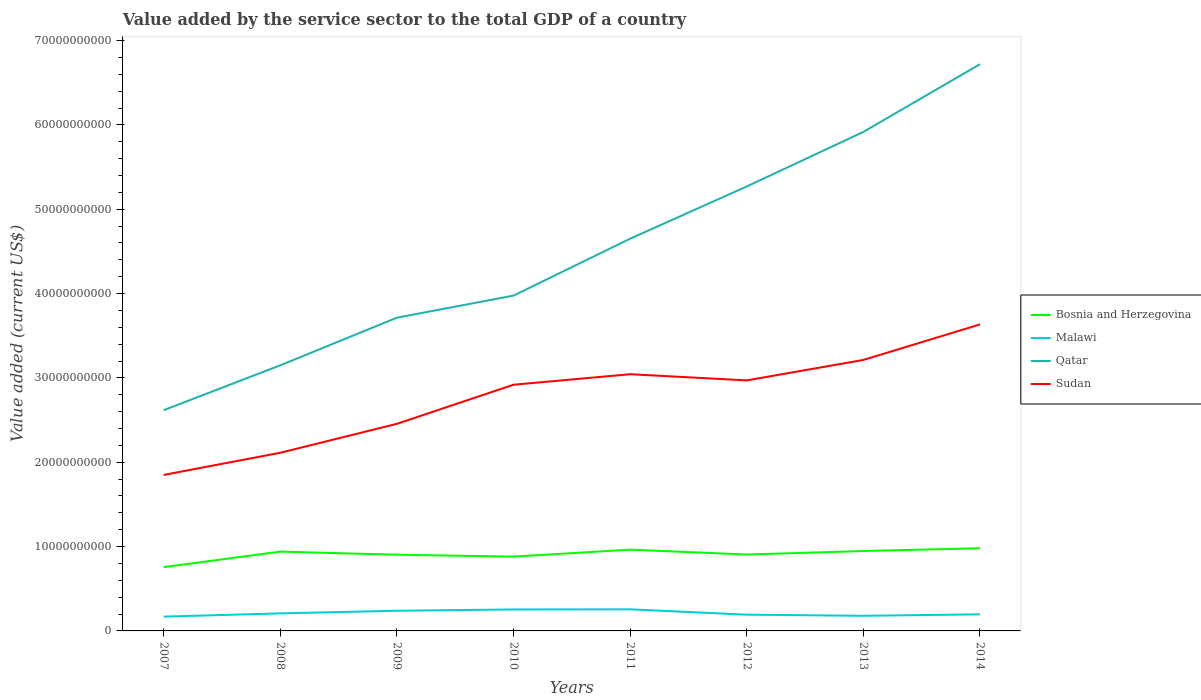Does the line corresponding to Malawi intersect with the line corresponding to Qatar?
Your response must be concise. No. Is the number of lines equal to the number of legend labels?
Offer a terse response. Yes. Across all years, what is the maximum value added by the service sector to the total GDP in Bosnia and Herzegovina?
Give a very brief answer. 7.56e+09. What is the total value added by the service sector to the total GDP in Sudan in the graph?
Offer a very short reply. -6.64e+09. What is the difference between the highest and the second highest value added by the service sector to the total GDP in Bosnia and Herzegovina?
Ensure brevity in your answer.  2.24e+09. What is the difference between the highest and the lowest value added by the service sector to the total GDP in Malawi?
Give a very brief answer. 3. How many lines are there?
Offer a terse response. 4. Are the values on the major ticks of Y-axis written in scientific E-notation?
Keep it short and to the point. No. Does the graph contain any zero values?
Your answer should be very brief. No. Does the graph contain grids?
Your answer should be very brief. No. Where does the legend appear in the graph?
Keep it short and to the point. Center right. How many legend labels are there?
Offer a terse response. 4. How are the legend labels stacked?
Provide a succinct answer. Vertical. What is the title of the graph?
Your answer should be very brief. Value added by the service sector to the total GDP of a country. Does "Djibouti" appear as one of the legend labels in the graph?
Provide a succinct answer. No. What is the label or title of the X-axis?
Keep it short and to the point. Years. What is the label or title of the Y-axis?
Offer a terse response. Value added (current US$). What is the Value added (current US$) of Bosnia and Herzegovina in 2007?
Ensure brevity in your answer.  7.56e+09. What is the Value added (current US$) in Malawi in 2007?
Your response must be concise. 1.69e+09. What is the Value added (current US$) in Qatar in 2007?
Your response must be concise. 2.62e+1. What is the Value added (current US$) in Sudan in 2007?
Give a very brief answer. 1.85e+1. What is the Value added (current US$) of Bosnia and Herzegovina in 2008?
Your response must be concise. 9.40e+09. What is the Value added (current US$) in Malawi in 2008?
Your answer should be compact. 2.08e+09. What is the Value added (current US$) of Qatar in 2008?
Keep it short and to the point. 3.15e+1. What is the Value added (current US$) in Sudan in 2008?
Make the answer very short. 2.11e+1. What is the Value added (current US$) in Bosnia and Herzegovina in 2009?
Keep it short and to the point. 9.04e+09. What is the Value added (current US$) in Malawi in 2009?
Keep it short and to the point. 2.39e+09. What is the Value added (current US$) in Qatar in 2009?
Keep it short and to the point. 3.71e+1. What is the Value added (current US$) of Sudan in 2009?
Provide a short and direct response. 2.46e+1. What is the Value added (current US$) in Bosnia and Herzegovina in 2010?
Your answer should be compact. 8.81e+09. What is the Value added (current US$) in Malawi in 2010?
Make the answer very short. 2.54e+09. What is the Value added (current US$) in Qatar in 2010?
Give a very brief answer. 3.98e+1. What is the Value added (current US$) in Sudan in 2010?
Make the answer very short. 2.92e+1. What is the Value added (current US$) of Bosnia and Herzegovina in 2011?
Ensure brevity in your answer.  9.64e+09. What is the Value added (current US$) in Malawi in 2011?
Give a very brief answer. 2.56e+09. What is the Value added (current US$) of Qatar in 2011?
Ensure brevity in your answer.  4.65e+1. What is the Value added (current US$) of Sudan in 2011?
Your answer should be very brief. 3.04e+1. What is the Value added (current US$) of Bosnia and Herzegovina in 2012?
Ensure brevity in your answer.  9.06e+09. What is the Value added (current US$) of Malawi in 2012?
Your answer should be compact. 1.93e+09. What is the Value added (current US$) of Qatar in 2012?
Your answer should be very brief. 5.27e+1. What is the Value added (current US$) in Sudan in 2012?
Give a very brief answer. 2.97e+1. What is the Value added (current US$) in Bosnia and Herzegovina in 2013?
Give a very brief answer. 9.47e+09. What is the Value added (current US$) of Malawi in 2013?
Your answer should be compact. 1.79e+09. What is the Value added (current US$) of Qatar in 2013?
Offer a terse response. 5.92e+1. What is the Value added (current US$) of Sudan in 2013?
Provide a succinct answer. 3.21e+1. What is the Value added (current US$) in Bosnia and Herzegovina in 2014?
Your answer should be very brief. 9.80e+09. What is the Value added (current US$) in Malawi in 2014?
Your answer should be compact. 1.97e+09. What is the Value added (current US$) in Qatar in 2014?
Keep it short and to the point. 6.72e+1. What is the Value added (current US$) of Sudan in 2014?
Offer a very short reply. 3.63e+1. Across all years, what is the maximum Value added (current US$) in Bosnia and Herzegovina?
Offer a very short reply. 9.80e+09. Across all years, what is the maximum Value added (current US$) of Malawi?
Keep it short and to the point. 2.56e+09. Across all years, what is the maximum Value added (current US$) of Qatar?
Your response must be concise. 6.72e+1. Across all years, what is the maximum Value added (current US$) of Sudan?
Keep it short and to the point. 3.63e+1. Across all years, what is the minimum Value added (current US$) in Bosnia and Herzegovina?
Provide a succinct answer. 7.56e+09. Across all years, what is the minimum Value added (current US$) in Malawi?
Your answer should be very brief. 1.69e+09. Across all years, what is the minimum Value added (current US$) in Qatar?
Your answer should be compact. 2.62e+1. Across all years, what is the minimum Value added (current US$) of Sudan?
Ensure brevity in your answer.  1.85e+1. What is the total Value added (current US$) of Bosnia and Herzegovina in the graph?
Provide a succinct answer. 7.28e+1. What is the total Value added (current US$) of Malawi in the graph?
Offer a terse response. 1.70e+1. What is the total Value added (current US$) of Qatar in the graph?
Ensure brevity in your answer.  3.60e+11. What is the total Value added (current US$) of Sudan in the graph?
Your answer should be very brief. 2.22e+11. What is the difference between the Value added (current US$) of Bosnia and Herzegovina in 2007 and that in 2008?
Keep it short and to the point. -1.84e+09. What is the difference between the Value added (current US$) of Malawi in 2007 and that in 2008?
Offer a terse response. -3.86e+08. What is the difference between the Value added (current US$) in Qatar in 2007 and that in 2008?
Give a very brief answer. -5.32e+09. What is the difference between the Value added (current US$) in Sudan in 2007 and that in 2008?
Keep it short and to the point. -2.63e+09. What is the difference between the Value added (current US$) of Bosnia and Herzegovina in 2007 and that in 2009?
Offer a terse response. -1.47e+09. What is the difference between the Value added (current US$) of Malawi in 2007 and that in 2009?
Keep it short and to the point. -6.97e+08. What is the difference between the Value added (current US$) in Qatar in 2007 and that in 2009?
Give a very brief answer. -1.10e+1. What is the difference between the Value added (current US$) of Sudan in 2007 and that in 2009?
Your answer should be compact. -6.06e+09. What is the difference between the Value added (current US$) in Bosnia and Herzegovina in 2007 and that in 2010?
Provide a short and direct response. -1.25e+09. What is the difference between the Value added (current US$) of Malawi in 2007 and that in 2010?
Give a very brief answer. -8.50e+08. What is the difference between the Value added (current US$) of Qatar in 2007 and that in 2010?
Offer a terse response. -1.36e+1. What is the difference between the Value added (current US$) in Sudan in 2007 and that in 2010?
Keep it short and to the point. -1.07e+1. What is the difference between the Value added (current US$) of Bosnia and Herzegovina in 2007 and that in 2011?
Your answer should be very brief. -2.07e+09. What is the difference between the Value added (current US$) of Malawi in 2007 and that in 2011?
Ensure brevity in your answer.  -8.66e+08. What is the difference between the Value added (current US$) in Qatar in 2007 and that in 2011?
Your answer should be very brief. -2.03e+1. What is the difference between the Value added (current US$) in Sudan in 2007 and that in 2011?
Ensure brevity in your answer.  -1.19e+1. What is the difference between the Value added (current US$) in Bosnia and Herzegovina in 2007 and that in 2012?
Your answer should be very brief. -1.49e+09. What is the difference between the Value added (current US$) of Malawi in 2007 and that in 2012?
Give a very brief answer. -2.32e+08. What is the difference between the Value added (current US$) of Qatar in 2007 and that in 2012?
Keep it short and to the point. -2.65e+1. What is the difference between the Value added (current US$) in Sudan in 2007 and that in 2012?
Give a very brief answer. -1.12e+1. What is the difference between the Value added (current US$) of Bosnia and Herzegovina in 2007 and that in 2013?
Make the answer very short. -1.91e+09. What is the difference between the Value added (current US$) in Malawi in 2007 and that in 2013?
Provide a succinct answer. -9.82e+07. What is the difference between the Value added (current US$) of Qatar in 2007 and that in 2013?
Offer a terse response. -3.30e+1. What is the difference between the Value added (current US$) of Sudan in 2007 and that in 2013?
Make the answer very short. -1.36e+1. What is the difference between the Value added (current US$) in Bosnia and Herzegovina in 2007 and that in 2014?
Your answer should be compact. -2.24e+09. What is the difference between the Value added (current US$) of Malawi in 2007 and that in 2014?
Offer a terse response. -2.74e+08. What is the difference between the Value added (current US$) of Qatar in 2007 and that in 2014?
Make the answer very short. -4.10e+1. What is the difference between the Value added (current US$) in Sudan in 2007 and that in 2014?
Offer a very short reply. -1.78e+1. What is the difference between the Value added (current US$) of Bosnia and Herzegovina in 2008 and that in 2009?
Ensure brevity in your answer.  3.69e+08. What is the difference between the Value added (current US$) in Malawi in 2008 and that in 2009?
Make the answer very short. -3.12e+08. What is the difference between the Value added (current US$) of Qatar in 2008 and that in 2009?
Your answer should be very brief. -5.65e+09. What is the difference between the Value added (current US$) of Sudan in 2008 and that in 2009?
Ensure brevity in your answer.  -3.43e+09. What is the difference between the Value added (current US$) in Bosnia and Herzegovina in 2008 and that in 2010?
Give a very brief answer. 5.95e+08. What is the difference between the Value added (current US$) of Malawi in 2008 and that in 2010?
Keep it short and to the point. -4.65e+08. What is the difference between the Value added (current US$) in Qatar in 2008 and that in 2010?
Offer a terse response. -8.27e+09. What is the difference between the Value added (current US$) of Sudan in 2008 and that in 2010?
Offer a terse response. -8.07e+09. What is the difference between the Value added (current US$) in Bosnia and Herzegovina in 2008 and that in 2011?
Your answer should be compact. -2.33e+08. What is the difference between the Value added (current US$) of Malawi in 2008 and that in 2011?
Provide a short and direct response. -4.81e+08. What is the difference between the Value added (current US$) in Qatar in 2008 and that in 2011?
Your answer should be compact. -1.50e+1. What is the difference between the Value added (current US$) of Sudan in 2008 and that in 2011?
Make the answer very short. -9.31e+09. What is the difference between the Value added (current US$) in Bosnia and Herzegovina in 2008 and that in 2012?
Keep it short and to the point. 3.47e+08. What is the difference between the Value added (current US$) of Malawi in 2008 and that in 2012?
Provide a short and direct response. 1.53e+08. What is the difference between the Value added (current US$) of Qatar in 2008 and that in 2012?
Offer a terse response. -2.12e+1. What is the difference between the Value added (current US$) in Sudan in 2008 and that in 2012?
Your response must be concise. -8.58e+09. What is the difference between the Value added (current US$) in Bosnia and Herzegovina in 2008 and that in 2013?
Give a very brief answer. -6.98e+07. What is the difference between the Value added (current US$) of Malawi in 2008 and that in 2013?
Keep it short and to the point. 2.87e+08. What is the difference between the Value added (current US$) in Qatar in 2008 and that in 2013?
Provide a short and direct response. -2.77e+1. What is the difference between the Value added (current US$) of Sudan in 2008 and that in 2013?
Your answer should be very brief. -1.10e+1. What is the difference between the Value added (current US$) of Bosnia and Herzegovina in 2008 and that in 2014?
Ensure brevity in your answer.  -4.00e+08. What is the difference between the Value added (current US$) in Malawi in 2008 and that in 2014?
Provide a succinct answer. 1.12e+08. What is the difference between the Value added (current US$) in Qatar in 2008 and that in 2014?
Offer a terse response. -3.57e+1. What is the difference between the Value added (current US$) in Sudan in 2008 and that in 2014?
Offer a terse response. -1.52e+1. What is the difference between the Value added (current US$) in Bosnia and Herzegovina in 2009 and that in 2010?
Offer a very short reply. 2.26e+08. What is the difference between the Value added (current US$) of Malawi in 2009 and that in 2010?
Your response must be concise. -1.53e+08. What is the difference between the Value added (current US$) of Qatar in 2009 and that in 2010?
Your answer should be compact. -2.62e+09. What is the difference between the Value added (current US$) of Sudan in 2009 and that in 2010?
Keep it short and to the point. -4.64e+09. What is the difference between the Value added (current US$) of Bosnia and Herzegovina in 2009 and that in 2011?
Offer a terse response. -6.02e+08. What is the difference between the Value added (current US$) in Malawi in 2009 and that in 2011?
Ensure brevity in your answer.  -1.69e+08. What is the difference between the Value added (current US$) of Qatar in 2009 and that in 2011?
Your response must be concise. -9.36e+09. What is the difference between the Value added (current US$) in Sudan in 2009 and that in 2011?
Give a very brief answer. -5.88e+09. What is the difference between the Value added (current US$) of Bosnia and Herzegovina in 2009 and that in 2012?
Ensure brevity in your answer.  -2.16e+07. What is the difference between the Value added (current US$) of Malawi in 2009 and that in 2012?
Provide a short and direct response. 4.65e+08. What is the difference between the Value added (current US$) in Qatar in 2009 and that in 2012?
Ensure brevity in your answer.  -1.56e+1. What is the difference between the Value added (current US$) of Sudan in 2009 and that in 2012?
Make the answer very short. -5.15e+09. What is the difference between the Value added (current US$) of Bosnia and Herzegovina in 2009 and that in 2013?
Offer a terse response. -4.38e+08. What is the difference between the Value added (current US$) of Malawi in 2009 and that in 2013?
Your response must be concise. 5.99e+08. What is the difference between the Value added (current US$) in Qatar in 2009 and that in 2013?
Provide a succinct answer. -2.20e+1. What is the difference between the Value added (current US$) of Sudan in 2009 and that in 2013?
Provide a succinct answer. -7.57e+09. What is the difference between the Value added (current US$) in Bosnia and Herzegovina in 2009 and that in 2014?
Provide a short and direct response. -7.69e+08. What is the difference between the Value added (current US$) in Malawi in 2009 and that in 2014?
Offer a terse response. 4.23e+08. What is the difference between the Value added (current US$) of Qatar in 2009 and that in 2014?
Your answer should be very brief. -3.01e+1. What is the difference between the Value added (current US$) of Sudan in 2009 and that in 2014?
Make the answer very short. -1.18e+1. What is the difference between the Value added (current US$) in Bosnia and Herzegovina in 2010 and that in 2011?
Your answer should be compact. -8.27e+08. What is the difference between the Value added (current US$) in Malawi in 2010 and that in 2011?
Provide a short and direct response. -1.59e+07. What is the difference between the Value added (current US$) in Qatar in 2010 and that in 2011?
Keep it short and to the point. -6.75e+09. What is the difference between the Value added (current US$) of Sudan in 2010 and that in 2011?
Provide a short and direct response. -1.25e+09. What is the difference between the Value added (current US$) of Bosnia and Herzegovina in 2010 and that in 2012?
Your response must be concise. -2.48e+08. What is the difference between the Value added (current US$) of Malawi in 2010 and that in 2012?
Your answer should be very brief. 6.18e+08. What is the difference between the Value added (current US$) in Qatar in 2010 and that in 2012?
Keep it short and to the point. -1.29e+1. What is the difference between the Value added (current US$) in Sudan in 2010 and that in 2012?
Offer a very short reply. -5.12e+08. What is the difference between the Value added (current US$) in Bosnia and Herzegovina in 2010 and that in 2013?
Provide a short and direct response. -6.64e+08. What is the difference between the Value added (current US$) in Malawi in 2010 and that in 2013?
Provide a short and direct response. 7.52e+08. What is the difference between the Value added (current US$) in Qatar in 2010 and that in 2013?
Ensure brevity in your answer.  -1.94e+1. What is the difference between the Value added (current US$) in Sudan in 2010 and that in 2013?
Keep it short and to the point. -2.94e+09. What is the difference between the Value added (current US$) of Bosnia and Herzegovina in 2010 and that in 2014?
Make the answer very short. -9.95e+08. What is the difference between the Value added (current US$) of Malawi in 2010 and that in 2014?
Give a very brief answer. 5.76e+08. What is the difference between the Value added (current US$) in Qatar in 2010 and that in 2014?
Give a very brief answer. -2.74e+1. What is the difference between the Value added (current US$) of Sudan in 2010 and that in 2014?
Keep it short and to the point. -7.15e+09. What is the difference between the Value added (current US$) of Bosnia and Herzegovina in 2011 and that in 2012?
Provide a succinct answer. 5.80e+08. What is the difference between the Value added (current US$) of Malawi in 2011 and that in 2012?
Your answer should be very brief. 6.34e+08. What is the difference between the Value added (current US$) in Qatar in 2011 and that in 2012?
Your answer should be compact. -6.19e+09. What is the difference between the Value added (current US$) of Sudan in 2011 and that in 2012?
Provide a short and direct response. 7.33e+08. What is the difference between the Value added (current US$) of Bosnia and Herzegovina in 2011 and that in 2013?
Provide a succinct answer. 1.63e+08. What is the difference between the Value added (current US$) in Malawi in 2011 and that in 2013?
Keep it short and to the point. 7.68e+08. What is the difference between the Value added (current US$) of Qatar in 2011 and that in 2013?
Your answer should be compact. -1.27e+1. What is the difference between the Value added (current US$) in Sudan in 2011 and that in 2013?
Your answer should be very brief. -1.69e+09. What is the difference between the Value added (current US$) in Bosnia and Herzegovina in 2011 and that in 2014?
Your answer should be compact. -1.67e+08. What is the difference between the Value added (current US$) of Malawi in 2011 and that in 2014?
Offer a very short reply. 5.92e+08. What is the difference between the Value added (current US$) of Qatar in 2011 and that in 2014?
Keep it short and to the point. -2.07e+1. What is the difference between the Value added (current US$) of Sudan in 2011 and that in 2014?
Give a very brief answer. -5.91e+09. What is the difference between the Value added (current US$) of Bosnia and Herzegovina in 2012 and that in 2013?
Ensure brevity in your answer.  -4.17e+08. What is the difference between the Value added (current US$) of Malawi in 2012 and that in 2013?
Give a very brief answer. 1.34e+08. What is the difference between the Value added (current US$) in Qatar in 2012 and that in 2013?
Ensure brevity in your answer.  -6.47e+09. What is the difference between the Value added (current US$) of Sudan in 2012 and that in 2013?
Provide a succinct answer. -2.43e+09. What is the difference between the Value added (current US$) in Bosnia and Herzegovina in 2012 and that in 2014?
Your response must be concise. -7.47e+08. What is the difference between the Value added (current US$) of Malawi in 2012 and that in 2014?
Your answer should be compact. -4.18e+07. What is the difference between the Value added (current US$) of Qatar in 2012 and that in 2014?
Your answer should be very brief. -1.45e+1. What is the difference between the Value added (current US$) of Sudan in 2012 and that in 2014?
Keep it short and to the point. -6.64e+09. What is the difference between the Value added (current US$) in Bosnia and Herzegovina in 2013 and that in 2014?
Offer a very short reply. -3.30e+08. What is the difference between the Value added (current US$) in Malawi in 2013 and that in 2014?
Your response must be concise. -1.76e+08. What is the difference between the Value added (current US$) in Qatar in 2013 and that in 2014?
Provide a short and direct response. -8.03e+09. What is the difference between the Value added (current US$) of Sudan in 2013 and that in 2014?
Keep it short and to the point. -4.22e+09. What is the difference between the Value added (current US$) in Bosnia and Herzegovina in 2007 and the Value added (current US$) in Malawi in 2008?
Give a very brief answer. 5.48e+09. What is the difference between the Value added (current US$) in Bosnia and Herzegovina in 2007 and the Value added (current US$) in Qatar in 2008?
Keep it short and to the point. -2.39e+1. What is the difference between the Value added (current US$) in Bosnia and Herzegovina in 2007 and the Value added (current US$) in Sudan in 2008?
Provide a short and direct response. -1.36e+1. What is the difference between the Value added (current US$) in Malawi in 2007 and the Value added (current US$) in Qatar in 2008?
Give a very brief answer. -2.98e+1. What is the difference between the Value added (current US$) in Malawi in 2007 and the Value added (current US$) in Sudan in 2008?
Keep it short and to the point. -1.94e+1. What is the difference between the Value added (current US$) of Qatar in 2007 and the Value added (current US$) of Sudan in 2008?
Offer a very short reply. 5.05e+09. What is the difference between the Value added (current US$) in Bosnia and Herzegovina in 2007 and the Value added (current US$) in Malawi in 2009?
Ensure brevity in your answer.  5.17e+09. What is the difference between the Value added (current US$) in Bosnia and Herzegovina in 2007 and the Value added (current US$) in Qatar in 2009?
Your answer should be very brief. -2.96e+1. What is the difference between the Value added (current US$) of Bosnia and Herzegovina in 2007 and the Value added (current US$) of Sudan in 2009?
Offer a terse response. -1.70e+1. What is the difference between the Value added (current US$) of Malawi in 2007 and the Value added (current US$) of Qatar in 2009?
Offer a terse response. -3.54e+1. What is the difference between the Value added (current US$) of Malawi in 2007 and the Value added (current US$) of Sudan in 2009?
Your answer should be compact. -2.29e+1. What is the difference between the Value added (current US$) in Qatar in 2007 and the Value added (current US$) in Sudan in 2009?
Offer a terse response. 1.62e+09. What is the difference between the Value added (current US$) of Bosnia and Herzegovina in 2007 and the Value added (current US$) of Malawi in 2010?
Provide a short and direct response. 5.02e+09. What is the difference between the Value added (current US$) in Bosnia and Herzegovina in 2007 and the Value added (current US$) in Qatar in 2010?
Offer a terse response. -3.22e+1. What is the difference between the Value added (current US$) in Bosnia and Herzegovina in 2007 and the Value added (current US$) in Sudan in 2010?
Your answer should be very brief. -2.16e+1. What is the difference between the Value added (current US$) of Malawi in 2007 and the Value added (current US$) of Qatar in 2010?
Keep it short and to the point. -3.81e+1. What is the difference between the Value added (current US$) of Malawi in 2007 and the Value added (current US$) of Sudan in 2010?
Provide a succinct answer. -2.75e+1. What is the difference between the Value added (current US$) of Qatar in 2007 and the Value added (current US$) of Sudan in 2010?
Ensure brevity in your answer.  -3.02e+09. What is the difference between the Value added (current US$) in Bosnia and Herzegovina in 2007 and the Value added (current US$) in Malawi in 2011?
Your answer should be very brief. 5.00e+09. What is the difference between the Value added (current US$) in Bosnia and Herzegovina in 2007 and the Value added (current US$) in Qatar in 2011?
Your response must be concise. -3.89e+1. What is the difference between the Value added (current US$) of Bosnia and Herzegovina in 2007 and the Value added (current US$) of Sudan in 2011?
Keep it short and to the point. -2.29e+1. What is the difference between the Value added (current US$) of Malawi in 2007 and the Value added (current US$) of Qatar in 2011?
Your answer should be compact. -4.48e+1. What is the difference between the Value added (current US$) in Malawi in 2007 and the Value added (current US$) in Sudan in 2011?
Provide a short and direct response. -2.87e+1. What is the difference between the Value added (current US$) of Qatar in 2007 and the Value added (current US$) of Sudan in 2011?
Ensure brevity in your answer.  -4.26e+09. What is the difference between the Value added (current US$) in Bosnia and Herzegovina in 2007 and the Value added (current US$) in Malawi in 2012?
Keep it short and to the point. 5.64e+09. What is the difference between the Value added (current US$) of Bosnia and Herzegovina in 2007 and the Value added (current US$) of Qatar in 2012?
Keep it short and to the point. -4.51e+1. What is the difference between the Value added (current US$) of Bosnia and Herzegovina in 2007 and the Value added (current US$) of Sudan in 2012?
Offer a terse response. -2.21e+1. What is the difference between the Value added (current US$) in Malawi in 2007 and the Value added (current US$) in Qatar in 2012?
Make the answer very short. -5.10e+1. What is the difference between the Value added (current US$) of Malawi in 2007 and the Value added (current US$) of Sudan in 2012?
Keep it short and to the point. -2.80e+1. What is the difference between the Value added (current US$) of Qatar in 2007 and the Value added (current US$) of Sudan in 2012?
Ensure brevity in your answer.  -3.53e+09. What is the difference between the Value added (current US$) of Bosnia and Herzegovina in 2007 and the Value added (current US$) of Malawi in 2013?
Keep it short and to the point. 5.77e+09. What is the difference between the Value added (current US$) in Bosnia and Herzegovina in 2007 and the Value added (current US$) in Qatar in 2013?
Give a very brief answer. -5.16e+1. What is the difference between the Value added (current US$) in Bosnia and Herzegovina in 2007 and the Value added (current US$) in Sudan in 2013?
Keep it short and to the point. -2.46e+1. What is the difference between the Value added (current US$) of Malawi in 2007 and the Value added (current US$) of Qatar in 2013?
Make the answer very short. -5.75e+1. What is the difference between the Value added (current US$) in Malawi in 2007 and the Value added (current US$) in Sudan in 2013?
Ensure brevity in your answer.  -3.04e+1. What is the difference between the Value added (current US$) of Qatar in 2007 and the Value added (current US$) of Sudan in 2013?
Make the answer very short. -5.96e+09. What is the difference between the Value added (current US$) in Bosnia and Herzegovina in 2007 and the Value added (current US$) in Malawi in 2014?
Give a very brief answer. 5.59e+09. What is the difference between the Value added (current US$) of Bosnia and Herzegovina in 2007 and the Value added (current US$) of Qatar in 2014?
Your response must be concise. -5.96e+1. What is the difference between the Value added (current US$) in Bosnia and Herzegovina in 2007 and the Value added (current US$) in Sudan in 2014?
Provide a succinct answer. -2.88e+1. What is the difference between the Value added (current US$) of Malawi in 2007 and the Value added (current US$) of Qatar in 2014?
Offer a terse response. -6.55e+1. What is the difference between the Value added (current US$) of Malawi in 2007 and the Value added (current US$) of Sudan in 2014?
Your response must be concise. -3.47e+1. What is the difference between the Value added (current US$) in Qatar in 2007 and the Value added (current US$) in Sudan in 2014?
Offer a very short reply. -1.02e+1. What is the difference between the Value added (current US$) of Bosnia and Herzegovina in 2008 and the Value added (current US$) of Malawi in 2009?
Give a very brief answer. 7.01e+09. What is the difference between the Value added (current US$) in Bosnia and Herzegovina in 2008 and the Value added (current US$) in Qatar in 2009?
Your answer should be very brief. -2.77e+1. What is the difference between the Value added (current US$) of Bosnia and Herzegovina in 2008 and the Value added (current US$) of Sudan in 2009?
Give a very brief answer. -1.52e+1. What is the difference between the Value added (current US$) of Malawi in 2008 and the Value added (current US$) of Qatar in 2009?
Provide a succinct answer. -3.51e+1. What is the difference between the Value added (current US$) of Malawi in 2008 and the Value added (current US$) of Sudan in 2009?
Offer a very short reply. -2.25e+1. What is the difference between the Value added (current US$) of Qatar in 2008 and the Value added (current US$) of Sudan in 2009?
Offer a very short reply. 6.94e+09. What is the difference between the Value added (current US$) in Bosnia and Herzegovina in 2008 and the Value added (current US$) in Malawi in 2010?
Provide a succinct answer. 6.86e+09. What is the difference between the Value added (current US$) in Bosnia and Herzegovina in 2008 and the Value added (current US$) in Qatar in 2010?
Provide a succinct answer. -3.04e+1. What is the difference between the Value added (current US$) in Bosnia and Herzegovina in 2008 and the Value added (current US$) in Sudan in 2010?
Your answer should be compact. -1.98e+1. What is the difference between the Value added (current US$) of Malawi in 2008 and the Value added (current US$) of Qatar in 2010?
Provide a short and direct response. -3.77e+1. What is the difference between the Value added (current US$) in Malawi in 2008 and the Value added (current US$) in Sudan in 2010?
Offer a very short reply. -2.71e+1. What is the difference between the Value added (current US$) in Qatar in 2008 and the Value added (current US$) in Sudan in 2010?
Ensure brevity in your answer.  2.30e+09. What is the difference between the Value added (current US$) in Bosnia and Herzegovina in 2008 and the Value added (current US$) in Malawi in 2011?
Provide a succinct answer. 6.84e+09. What is the difference between the Value added (current US$) in Bosnia and Herzegovina in 2008 and the Value added (current US$) in Qatar in 2011?
Your response must be concise. -3.71e+1. What is the difference between the Value added (current US$) in Bosnia and Herzegovina in 2008 and the Value added (current US$) in Sudan in 2011?
Make the answer very short. -2.10e+1. What is the difference between the Value added (current US$) in Malawi in 2008 and the Value added (current US$) in Qatar in 2011?
Make the answer very short. -4.44e+1. What is the difference between the Value added (current US$) of Malawi in 2008 and the Value added (current US$) of Sudan in 2011?
Your response must be concise. -2.84e+1. What is the difference between the Value added (current US$) of Qatar in 2008 and the Value added (current US$) of Sudan in 2011?
Ensure brevity in your answer.  1.06e+09. What is the difference between the Value added (current US$) of Bosnia and Herzegovina in 2008 and the Value added (current US$) of Malawi in 2012?
Offer a very short reply. 7.48e+09. What is the difference between the Value added (current US$) in Bosnia and Herzegovina in 2008 and the Value added (current US$) in Qatar in 2012?
Provide a short and direct response. -4.33e+1. What is the difference between the Value added (current US$) of Bosnia and Herzegovina in 2008 and the Value added (current US$) of Sudan in 2012?
Make the answer very short. -2.03e+1. What is the difference between the Value added (current US$) of Malawi in 2008 and the Value added (current US$) of Qatar in 2012?
Give a very brief answer. -5.06e+1. What is the difference between the Value added (current US$) in Malawi in 2008 and the Value added (current US$) in Sudan in 2012?
Your answer should be compact. -2.76e+1. What is the difference between the Value added (current US$) of Qatar in 2008 and the Value added (current US$) of Sudan in 2012?
Provide a succinct answer. 1.79e+09. What is the difference between the Value added (current US$) of Bosnia and Herzegovina in 2008 and the Value added (current US$) of Malawi in 2013?
Offer a terse response. 7.61e+09. What is the difference between the Value added (current US$) in Bosnia and Herzegovina in 2008 and the Value added (current US$) in Qatar in 2013?
Provide a short and direct response. -4.98e+1. What is the difference between the Value added (current US$) of Bosnia and Herzegovina in 2008 and the Value added (current US$) of Sudan in 2013?
Your response must be concise. -2.27e+1. What is the difference between the Value added (current US$) of Malawi in 2008 and the Value added (current US$) of Qatar in 2013?
Make the answer very short. -5.71e+1. What is the difference between the Value added (current US$) of Malawi in 2008 and the Value added (current US$) of Sudan in 2013?
Your answer should be compact. -3.00e+1. What is the difference between the Value added (current US$) in Qatar in 2008 and the Value added (current US$) in Sudan in 2013?
Your response must be concise. -6.36e+08. What is the difference between the Value added (current US$) of Bosnia and Herzegovina in 2008 and the Value added (current US$) of Malawi in 2014?
Provide a short and direct response. 7.44e+09. What is the difference between the Value added (current US$) of Bosnia and Herzegovina in 2008 and the Value added (current US$) of Qatar in 2014?
Make the answer very short. -5.78e+1. What is the difference between the Value added (current US$) of Bosnia and Herzegovina in 2008 and the Value added (current US$) of Sudan in 2014?
Offer a terse response. -2.69e+1. What is the difference between the Value added (current US$) in Malawi in 2008 and the Value added (current US$) in Qatar in 2014?
Your response must be concise. -6.51e+1. What is the difference between the Value added (current US$) in Malawi in 2008 and the Value added (current US$) in Sudan in 2014?
Ensure brevity in your answer.  -3.43e+1. What is the difference between the Value added (current US$) of Qatar in 2008 and the Value added (current US$) of Sudan in 2014?
Offer a terse response. -4.85e+09. What is the difference between the Value added (current US$) in Bosnia and Herzegovina in 2009 and the Value added (current US$) in Malawi in 2010?
Provide a succinct answer. 6.49e+09. What is the difference between the Value added (current US$) in Bosnia and Herzegovina in 2009 and the Value added (current US$) in Qatar in 2010?
Your answer should be very brief. -3.07e+1. What is the difference between the Value added (current US$) of Bosnia and Herzegovina in 2009 and the Value added (current US$) of Sudan in 2010?
Offer a terse response. -2.02e+1. What is the difference between the Value added (current US$) in Malawi in 2009 and the Value added (current US$) in Qatar in 2010?
Offer a terse response. -3.74e+1. What is the difference between the Value added (current US$) of Malawi in 2009 and the Value added (current US$) of Sudan in 2010?
Make the answer very short. -2.68e+1. What is the difference between the Value added (current US$) of Qatar in 2009 and the Value added (current US$) of Sudan in 2010?
Make the answer very short. 7.95e+09. What is the difference between the Value added (current US$) of Bosnia and Herzegovina in 2009 and the Value added (current US$) of Malawi in 2011?
Your answer should be very brief. 6.47e+09. What is the difference between the Value added (current US$) of Bosnia and Herzegovina in 2009 and the Value added (current US$) of Qatar in 2011?
Offer a very short reply. -3.75e+1. What is the difference between the Value added (current US$) in Bosnia and Herzegovina in 2009 and the Value added (current US$) in Sudan in 2011?
Your response must be concise. -2.14e+1. What is the difference between the Value added (current US$) in Malawi in 2009 and the Value added (current US$) in Qatar in 2011?
Keep it short and to the point. -4.41e+1. What is the difference between the Value added (current US$) in Malawi in 2009 and the Value added (current US$) in Sudan in 2011?
Ensure brevity in your answer.  -2.80e+1. What is the difference between the Value added (current US$) in Qatar in 2009 and the Value added (current US$) in Sudan in 2011?
Make the answer very short. 6.70e+09. What is the difference between the Value added (current US$) of Bosnia and Herzegovina in 2009 and the Value added (current US$) of Malawi in 2012?
Keep it short and to the point. 7.11e+09. What is the difference between the Value added (current US$) in Bosnia and Herzegovina in 2009 and the Value added (current US$) in Qatar in 2012?
Your answer should be compact. -4.37e+1. What is the difference between the Value added (current US$) of Bosnia and Herzegovina in 2009 and the Value added (current US$) of Sudan in 2012?
Provide a short and direct response. -2.07e+1. What is the difference between the Value added (current US$) in Malawi in 2009 and the Value added (current US$) in Qatar in 2012?
Your answer should be very brief. -5.03e+1. What is the difference between the Value added (current US$) in Malawi in 2009 and the Value added (current US$) in Sudan in 2012?
Your answer should be very brief. -2.73e+1. What is the difference between the Value added (current US$) of Qatar in 2009 and the Value added (current US$) of Sudan in 2012?
Your answer should be very brief. 7.44e+09. What is the difference between the Value added (current US$) of Bosnia and Herzegovina in 2009 and the Value added (current US$) of Malawi in 2013?
Provide a succinct answer. 7.24e+09. What is the difference between the Value added (current US$) of Bosnia and Herzegovina in 2009 and the Value added (current US$) of Qatar in 2013?
Make the answer very short. -5.01e+1. What is the difference between the Value added (current US$) in Bosnia and Herzegovina in 2009 and the Value added (current US$) in Sudan in 2013?
Ensure brevity in your answer.  -2.31e+1. What is the difference between the Value added (current US$) of Malawi in 2009 and the Value added (current US$) of Qatar in 2013?
Keep it short and to the point. -5.68e+1. What is the difference between the Value added (current US$) in Malawi in 2009 and the Value added (current US$) in Sudan in 2013?
Provide a short and direct response. -2.97e+1. What is the difference between the Value added (current US$) of Qatar in 2009 and the Value added (current US$) of Sudan in 2013?
Your response must be concise. 5.01e+09. What is the difference between the Value added (current US$) in Bosnia and Herzegovina in 2009 and the Value added (current US$) in Malawi in 2014?
Keep it short and to the point. 7.07e+09. What is the difference between the Value added (current US$) in Bosnia and Herzegovina in 2009 and the Value added (current US$) in Qatar in 2014?
Provide a succinct answer. -5.82e+1. What is the difference between the Value added (current US$) of Bosnia and Herzegovina in 2009 and the Value added (current US$) of Sudan in 2014?
Keep it short and to the point. -2.73e+1. What is the difference between the Value added (current US$) of Malawi in 2009 and the Value added (current US$) of Qatar in 2014?
Give a very brief answer. -6.48e+1. What is the difference between the Value added (current US$) in Malawi in 2009 and the Value added (current US$) in Sudan in 2014?
Provide a short and direct response. -3.40e+1. What is the difference between the Value added (current US$) of Qatar in 2009 and the Value added (current US$) of Sudan in 2014?
Provide a succinct answer. 7.97e+08. What is the difference between the Value added (current US$) in Bosnia and Herzegovina in 2010 and the Value added (current US$) in Malawi in 2011?
Keep it short and to the point. 6.25e+09. What is the difference between the Value added (current US$) of Bosnia and Herzegovina in 2010 and the Value added (current US$) of Qatar in 2011?
Your response must be concise. -3.77e+1. What is the difference between the Value added (current US$) of Bosnia and Herzegovina in 2010 and the Value added (current US$) of Sudan in 2011?
Keep it short and to the point. -2.16e+1. What is the difference between the Value added (current US$) in Malawi in 2010 and the Value added (current US$) in Qatar in 2011?
Your answer should be compact. -4.40e+1. What is the difference between the Value added (current US$) of Malawi in 2010 and the Value added (current US$) of Sudan in 2011?
Your answer should be compact. -2.79e+1. What is the difference between the Value added (current US$) of Qatar in 2010 and the Value added (current US$) of Sudan in 2011?
Your answer should be very brief. 9.32e+09. What is the difference between the Value added (current US$) in Bosnia and Herzegovina in 2010 and the Value added (current US$) in Malawi in 2012?
Give a very brief answer. 6.88e+09. What is the difference between the Value added (current US$) of Bosnia and Herzegovina in 2010 and the Value added (current US$) of Qatar in 2012?
Provide a short and direct response. -4.39e+1. What is the difference between the Value added (current US$) in Bosnia and Herzegovina in 2010 and the Value added (current US$) in Sudan in 2012?
Offer a very short reply. -2.09e+1. What is the difference between the Value added (current US$) in Malawi in 2010 and the Value added (current US$) in Qatar in 2012?
Your response must be concise. -5.02e+1. What is the difference between the Value added (current US$) in Malawi in 2010 and the Value added (current US$) in Sudan in 2012?
Your answer should be very brief. -2.72e+1. What is the difference between the Value added (current US$) in Qatar in 2010 and the Value added (current US$) in Sudan in 2012?
Offer a terse response. 1.01e+1. What is the difference between the Value added (current US$) of Bosnia and Herzegovina in 2010 and the Value added (current US$) of Malawi in 2013?
Your answer should be compact. 7.02e+09. What is the difference between the Value added (current US$) in Bosnia and Herzegovina in 2010 and the Value added (current US$) in Qatar in 2013?
Make the answer very short. -5.04e+1. What is the difference between the Value added (current US$) in Bosnia and Herzegovina in 2010 and the Value added (current US$) in Sudan in 2013?
Offer a terse response. -2.33e+1. What is the difference between the Value added (current US$) in Malawi in 2010 and the Value added (current US$) in Qatar in 2013?
Your response must be concise. -5.66e+1. What is the difference between the Value added (current US$) of Malawi in 2010 and the Value added (current US$) of Sudan in 2013?
Your answer should be very brief. -2.96e+1. What is the difference between the Value added (current US$) in Qatar in 2010 and the Value added (current US$) in Sudan in 2013?
Keep it short and to the point. 7.63e+09. What is the difference between the Value added (current US$) of Bosnia and Herzegovina in 2010 and the Value added (current US$) of Malawi in 2014?
Give a very brief answer. 6.84e+09. What is the difference between the Value added (current US$) in Bosnia and Herzegovina in 2010 and the Value added (current US$) in Qatar in 2014?
Offer a terse response. -5.84e+1. What is the difference between the Value added (current US$) of Bosnia and Herzegovina in 2010 and the Value added (current US$) of Sudan in 2014?
Provide a succinct answer. -2.75e+1. What is the difference between the Value added (current US$) in Malawi in 2010 and the Value added (current US$) in Qatar in 2014?
Ensure brevity in your answer.  -6.46e+1. What is the difference between the Value added (current US$) in Malawi in 2010 and the Value added (current US$) in Sudan in 2014?
Ensure brevity in your answer.  -3.38e+1. What is the difference between the Value added (current US$) in Qatar in 2010 and the Value added (current US$) in Sudan in 2014?
Provide a succinct answer. 3.41e+09. What is the difference between the Value added (current US$) of Bosnia and Herzegovina in 2011 and the Value added (current US$) of Malawi in 2012?
Keep it short and to the point. 7.71e+09. What is the difference between the Value added (current US$) in Bosnia and Herzegovina in 2011 and the Value added (current US$) in Qatar in 2012?
Offer a very short reply. -4.31e+1. What is the difference between the Value added (current US$) in Bosnia and Herzegovina in 2011 and the Value added (current US$) in Sudan in 2012?
Keep it short and to the point. -2.01e+1. What is the difference between the Value added (current US$) in Malawi in 2011 and the Value added (current US$) in Qatar in 2012?
Offer a terse response. -5.01e+1. What is the difference between the Value added (current US$) of Malawi in 2011 and the Value added (current US$) of Sudan in 2012?
Ensure brevity in your answer.  -2.71e+1. What is the difference between the Value added (current US$) of Qatar in 2011 and the Value added (current US$) of Sudan in 2012?
Your response must be concise. 1.68e+1. What is the difference between the Value added (current US$) of Bosnia and Herzegovina in 2011 and the Value added (current US$) of Malawi in 2013?
Your answer should be compact. 7.84e+09. What is the difference between the Value added (current US$) of Bosnia and Herzegovina in 2011 and the Value added (current US$) of Qatar in 2013?
Provide a short and direct response. -4.95e+1. What is the difference between the Value added (current US$) in Bosnia and Herzegovina in 2011 and the Value added (current US$) in Sudan in 2013?
Make the answer very short. -2.25e+1. What is the difference between the Value added (current US$) in Malawi in 2011 and the Value added (current US$) in Qatar in 2013?
Provide a succinct answer. -5.66e+1. What is the difference between the Value added (current US$) of Malawi in 2011 and the Value added (current US$) of Sudan in 2013?
Keep it short and to the point. -2.96e+1. What is the difference between the Value added (current US$) in Qatar in 2011 and the Value added (current US$) in Sudan in 2013?
Your answer should be compact. 1.44e+1. What is the difference between the Value added (current US$) in Bosnia and Herzegovina in 2011 and the Value added (current US$) in Malawi in 2014?
Your answer should be very brief. 7.67e+09. What is the difference between the Value added (current US$) in Bosnia and Herzegovina in 2011 and the Value added (current US$) in Qatar in 2014?
Give a very brief answer. -5.76e+1. What is the difference between the Value added (current US$) of Bosnia and Herzegovina in 2011 and the Value added (current US$) of Sudan in 2014?
Ensure brevity in your answer.  -2.67e+1. What is the difference between the Value added (current US$) of Malawi in 2011 and the Value added (current US$) of Qatar in 2014?
Your answer should be very brief. -6.46e+1. What is the difference between the Value added (current US$) of Malawi in 2011 and the Value added (current US$) of Sudan in 2014?
Provide a succinct answer. -3.38e+1. What is the difference between the Value added (current US$) of Qatar in 2011 and the Value added (current US$) of Sudan in 2014?
Your response must be concise. 1.02e+1. What is the difference between the Value added (current US$) of Bosnia and Herzegovina in 2012 and the Value added (current US$) of Malawi in 2013?
Provide a succinct answer. 7.26e+09. What is the difference between the Value added (current US$) in Bosnia and Herzegovina in 2012 and the Value added (current US$) in Qatar in 2013?
Offer a very short reply. -5.01e+1. What is the difference between the Value added (current US$) of Bosnia and Herzegovina in 2012 and the Value added (current US$) of Sudan in 2013?
Your response must be concise. -2.31e+1. What is the difference between the Value added (current US$) of Malawi in 2012 and the Value added (current US$) of Qatar in 2013?
Your answer should be very brief. -5.72e+1. What is the difference between the Value added (current US$) of Malawi in 2012 and the Value added (current US$) of Sudan in 2013?
Give a very brief answer. -3.02e+1. What is the difference between the Value added (current US$) of Qatar in 2012 and the Value added (current US$) of Sudan in 2013?
Keep it short and to the point. 2.06e+1. What is the difference between the Value added (current US$) in Bosnia and Herzegovina in 2012 and the Value added (current US$) in Malawi in 2014?
Provide a succinct answer. 7.09e+09. What is the difference between the Value added (current US$) of Bosnia and Herzegovina in 2012 and the Value added (current US$) of Qatar in 2014?
Your response must be concise. -5.81e+1. What is the difference between the Value added (current US$) of Bosnia and Herzegovina in 2012 and the Value added (current US$) of Sudan in 2014?
Keep it short and to the point. -2.73e+1. What is the difference between the Value added (current US$) in Malawi in 2012 and the Value added (current US$) in Qatar in 2014?
Your response must be concise. -6.53e+1. What is the difference between the Value added (current US$) in Malawi in 2012 and the Value added (current US$) in Sudan in 2014?
Give a very brief answer. -3.44e+1. What is the difference between the Value added (current US$) of Qatar in 2012 and the Value added (current US$) of Sudan in 2014?
Ensure brevity in your answer.  1.64e+1. What is the difference between the Value added (current US$) of Bosnia and Herzegovina in 2013 and the Value added (current US$) of Malawi in 2014?
Provide a succinct answer. 7.51e+09. What is the difference between the Value added (current US$) of Bosnia and Herzegovina in 2013 and the Value added (current US$) of Qatar in 2014?
Give a very brief answer. -5.77e+1. What is the difference between the Value added (current US$) of Bosnia and Herzegovina in 2013 and the Value added (current US$) of Sudan in 2014?
Your response must be concise. -2.69e+1. What is the difference between the Value added (current US$) in Malawi in 2013 and the Value added (current US$) in Qatar in 2014?
Offer a very short reply. -6.54e+1. What is the difference between the Value added (current US$) in Malawi in 2013 and the Value added (current US$) in Sudan in 2014?
Ensure brevity in your answer.  -3.46e+1. What is the difference between the Value added (current US$) of Qatar in 2013 and the Value added (current US$) of Sudan in 2014?
Ensure brevity in your answer.  2.28e+1. What is the average Value added (current US$) in Bosnia and Herzegovina per year?
Your response must be concise. 9.10e+09. What is the average Value added (current US$) of Malawi per year?
Make the answer very short. 2.12e+09. What is the average Value added (current US$) in Qatar per year?
Make the answer very short. 4.50e+1. What is the average Value added (current US$) in Sudan per year?
Offer a very short reply. 2.77e+1. In the year 2007, what is the difference between the Value added (current US$) in Bosnia and Herzegovina and Value added (current US$) in Malawi?
Keep it short and to the point. 5.87e+09. In the year 2007, what is the difference between the Value added (current US$) in Bosnia and Herzegovina and Value added (current US$) in Qatar?
Your response must be concise. -1.86e+1. In the year 2007, what is the difference between the Value added (current US$) in Bosnia and Herzegovina and Value added (current US$) in Sudan?
Keep it short and to the point. -1.09e+1. In the year 2007, what is the difference between the Value added (current US$) in Malawi and Value added (current US$) in Qatar?
Your answer should be very brief. -2.45e+1. In the year 2007, what is the difference between the Value added (current US$) in Malawi and Value added (current US$) in Sudan?
Your response must be concise. -1.68e+1. In the year 2007, what is the difference between the Value added (current US$) of Qatar and Value added (current US$) of Sudan?
Keep it short and to the point. 7.67e+09. In the year 2008, what is the difference between the Value added (current US$) in Bosnia and Herzegovina and Value added (current US$) in Malawi?
Give a very brief answer. 7.32e+09. In the year 2008, what is the difference between the Value added (current US$) of Bosnia and Herzegovina and Value added (current US$) of Qatar?
Make the answer very short. -2.21e+1. In the year 2008, what is the difference between the Value added (current US$) in Bosnia and Herzegovina and Value added (current US$) in Sudan?
Make the answer very short. -1.17e+1. In the year 2008, what is the difference between the Value added (current US$) in Malawi and Value added (current US$) in Qatar?
Offer a very short reply. -2.94e+1. In the year 2008, what is the difference between the Value added (current US$) in Malawi and Value added (current US$) in Sudan?
Offer a very short reply. -1.90e+1. In the year 2008, what is the difference between the Value added (current US$) in Qatar and Value added (current US$) in Sudan?
Make the answer very short. 1.04e+1. In the year 2009, what is the difference between the Value added (current US$) of Bosnia and Herzegovina and Value added (current US$) of Malawi?
Your answer should be compact. 6.64e+09. In the year 2009, what is the difference between the Value added (current US$) of Bosnia and Herzegovina and Value added (current US$) of Qatar?
Your response must be concise. -2.81e+1. In the year 2009, what is the difference between the Value added (current US$) of Bosnia and Herzegovina and Value added (current US$) of Sudan?
Provide a succinct answer. -1.55e+1. In the year 2009, what is the difference between the Value added (current US$) of Malawi and Value added (current US$) of Qatar?
Your answer should be very brief. -3.47e+1. In the year 2009, what is the difference between the Value added (current US$) of Malawi and Value added (current US$) of Sudan?
Keep it short and to the point. -2.22e+1. In the year 2009, what is the difference between the Value added (current US$) of Qatar and Value added (current US$) of Sudan?
Your response must be concise. 1.26e+1. In the year 2010, what is the difference between the Value added (current US$) of Bosnia and Herzegovina and Value added (current US$) of Malawi?
Make the answer very short. 6.26e+09. In the year 2010, what is the difference between the Value added (current US$) in Bosnia and Herzegovina and Value added (current US$) in Qatar?
Ensure brevity in your answer.  -3.09e+1. In the year 2010, what is the difference between the Value added (current US$) in Bosnia and Herzegovina and Value added (current US$) in Sudan?
Your answer should be compact. -2.04e+1. In the year 2010, what is the difference between the Value added (current US$) in Malawi and Value added (current US$) in Qatar?
Ensure brevity in your answer.  -3.72e+1. In the year 2010, what is the difference between the Value added (current US$) of Malawi and Value added (current US$) of Sudan?
Provide a succinct answer. -2.66e+1. In the year 2010, what is the difference between the Value added (current US$) of Qatar and Value added (current US$) of Sudan?
Ensure brevity in your answer.  1.06e+1. In the year 2011, what is the difference between the Value added (current US$) of Bosnia and Herzegovina and Value added (current US$) of Malawi?
Provide a short and direct response. 7.08e+09. In the year 2011, what is the difference between the Value added (current US$) of Bosnia and Herzegovina and Value added (current US$) of Qatar?
Offer a very short reply. -3.69e+1. In the year 2011, what is the difference between the Value added (current US$) of Bosnia and Herzegovina and Value added (current US$) of Sudan?
Your answer should be very brief. -2.08e+1. In the year 2011, what is the difference between the Value added (current US$) of Malawi and Value added (current US$) of Qatar?
Your answer should be very brief. -4.39e+1. In the year 2011, what is the difference between the Value added (current US$) of Malawi and Value added (current US$) of Sudan?
Provide a short and direct response. -2.79e+1. In the year 2011, what is the difference between the Value added (current US$) in Qatar and Value added (current US$) in Sudan?
Give a very brief answer. 1.61e+1. In the year 2012, what is the difference between the Value added (current US$) of Bosnia and Herzegovina and Value added (current US$) of Malawi?
Your answer should be compact. 7.13e+09. In the year 2012, what is the difference between the Value added (current US$) of Bosnia and Herzegovina and Value added (current US$) of Qatar?
Your response must be concise. -4.36e+1. In the year 2012, what is the difference between the Value added (current US$) in Bosnia and Herzegovina and Value added (current US$) in Sudan?
Your answer should be very brief. -2.06e+1. In the year 2012, what is the difference between the Value added (current US$) in Malawi and Value added (current US$) in Qatar?
Offer a terse response. -5.08e+1. In the year 2012, what is the difference between the Value added (current US$) of Malawi and Value added (current US$) of Sudan?
Your answer should be very brief. -2.78e+1. In the year 2012, what is the difference between the Value added (current US$) in Qatar and Value added (current US$) in Sudan?
Provide a short and direct response. 2.30e+1. In the year 2013, what is the difference between the Value added (current US$) of Bosnia and Herzegovina and Value added (current US$) of Malawi?
Ensure brevity in your answer.  7.68e+09. In the year 2013, what is the difference between the Value added (current US$) in Bosnia and Herzegovina and Value added (current US$) in Qatar?
Your answer should be very brief. -4.97e+1. In the year 2013, what is the difference between the Value added (current US$) in Bosnia and Herzegovina and Value added (current US$) in Sudan?
Keep it short and to the point. -2.27e+1. In the year 2013, what is the difference between the Value added (current US$) of Malawi and Value added (current US$) of Qatar?
Give a very brief answer. -5.74e+1. In the year 2013, what is the difference between the Value added (current US$) in Malawi and Value added (current US$) in Sudan?
Make the answer very short. -3.03e+1. In the year 2013, what is the difference between the Value added (current US$) in Qatar and Value added (current US$) in Sudan?
Your answer should be compact. 2.70e+1. In the year 2014, what is the difference between the Value added (current US$) in Bosnia and Herzegovina and Value added (current US$) in Malawi?
Ensure brevity in your answer.  7.84e+09. In the year 2014, what is the difference between the Value added (current US$) in Bosnia and Herzegovina and Value added (current US$) in Qatar?
Offer a terse response. -5.74e+1. In the year 2014, what is the difference between the Value added (current US$) in Bosnia and Herzegovina and Value added (current US$) in Sudan?
Provide a succinct answer. -2.65e+1. In the year 2014, what is the difference between the Value added (current US$) of Malawi and Value added (current US$) of Qatar?
Provide a short and direct response. -6.52e+1. In the year 2014, what is the difference between the Value added (current US$) of Malawi and Value added (current US$) of Sudan?
Provide a succinct answer. -3.44e+1. In the year 2014, what is the difference between the Value added (current US$) of Qatar and Value added (current US$) of Sudan?
Offer a terse response. 3.08e+1. What is the ratio of the Value added (current US$) of Bosnia and Herzegovina in 2007 to that in 2008?
Your answer should be compact. 0.8. What is the ratio of the Value added (current US$) in Malawi in 2007 to that in 2008?
Keep it short and to the point. 0.81. What is the ratio of the Value added (current US$) of Qatar in 2007 to that in 2008?
Ensure brevity in your answer.  0.83. What is the ratio of the Value added (current US$) of Sudan in 2007 to that in 2008?
Your answer should be very brief. 0.88. What is the ratio of the Value added (current US$) in Bosnia and Herzegovina in 2007 to that in 2009?
Offer a terse response. 0.84. What is the ratio of the Value added (current US$) in Malawi in 2007 to that in 2009?
Provide a short and direct response. 0.71. What is the ratio of the Value added (current US$) of Qatar in 2007 to that in 2009?
Provide a succinct answer. 0.7. What is the ratio of the Value added (current US$) of Sudan in 2007 to that in 2009?
Your answer should be very brief. 0.75. What is the ratio of the Value added (current US$) of Bosnia and Herzegovina in 2007 to that in 2010?
Your answer should be very brief. 0.86. What is the ratio of the Value added (current US$) of Malawi in 2007 to that in 2010?
Ensure brevity in your answer.  0.67. What is the ratio of the Value added (current US$) of Qatar in 2007 to that in 2010?
Ensure brevity in your answer.  0.66. What is the ratio of the Value added (current US$) in Sudan in 2007 to that in 2010?
Make the answer very short. 0.63. What is the ratio of the Value added (current US$) in Bosnia and Herzegovina in 2007 to that in 2011?
Your answer should be very brief. 0.78. What is the ratio of the Value added (current US$) in Malawi in 2007 to that in 2011?
Make the answer very short. 0.66. What is the ratio of the Value added (current US$) of Qatar in 2007 to that in 2011?
Give a very brief answer. 0.56. What is the ratio of the Value added (current US$) in Sudan in 2007 to that in 2011?
Offer a terse response. 0.61. What is the ratio of the Value added (current US$) of Bosnia and Herzegovina in 2007 to that in 2012?
Keep it short and to the point. 0.83. What is the ratio of the Value added (current US$) in Malawi in 2007 to that in 2012?
Your answer should be very brief. 0.88. What is the ratio of the Value added (current US$) in Qatar in 2007 to that in 2012?
Give a very brief answer. 0.5. What is the ratio of the Value added (current US$) of Sudan in 2007 to that in 2012?
Give a very brief answer. 0.62. What is the ratio of the Value added (current US$) in Bosnia and Herzegovina in 2007 to that in 2013?
Give a very brief answer. 0.8. What is the ratio of the Value added (current US$) in Malawi in 2007 to that in 2013?
Provide a short and direct response. 0.95. What is the ratio of the Value added (current US$) of Qatar in 2007 to that in 2013?
Make the answer very short. 0.44. What is the ratio of the Value added (current US$) of Sudan in 2007 to that in 2013?
Offer a terse response. 0.58. What is the ratio of the Value added (current US$) of Bosnia and Herzegovina in 2007 to that in 2014?
Offer a terse response. 0.77. What is the ratio of the Value added (current US$) in Malawi in 2007 to that in 2014?
Your answer should be very brief. 0.86. What is the ratio of the Value added (current US$) of Qatar in 2007 to that in 2014?
Give a very brief answer. 0.39. What is the ratio of the Value added (current US$) of Sudan in 2007 to that in 2014?
Provide a short and direct response. 0.51. What is the ratio of the Value added (current US$) of Bosnia and Herzegovina in 2008 to that in 2009?
Keep it short and to the point. 1.04. What is the ratio of the Value added (current US$) in Malawi in 2008 to that in 2009?
Offer a terse response. 0.87. What is the ratio of the Value added (current US$) in Qatar in 2008 to that in 2009?
Keep it short and to the point. 0.85. What is the ratio of the Value added (current US$) in Sudan in 2008 to that in 2009?
Provide a succinct answer. 0.86. What is the ratio of the Value added (current US$) of Bosnia and Herzegovina in 2008 to that in 2010?
Keep it short and to the point. 1.07. What is the ratio of the Value added (current US$) in Malawi in 2008 to that in 2010?
Offer a very short reply. 0.82. What is the ratio of the Value added (current US$) in Qatar in 2008 to that in 2010?
Offer a terse response. 0.79. What is the ratio of the Value added (current US$) in Sudan in 2008 to that in 2010?
Give a very brief answer. 0.72. What is the ratio of the Value added (current US$) of Bosnia and Herzegovina in 2008 to that in 2011?
Keep it short and to the point. 0.98. What is the ratio of the Value added (current US$) in Malawi in 2008 to that in 2011?
Your answer should be very brief. 0.81. What is the ratio of the Value added (current US$) of Qatar in 2008 to that in 2011?
Your answer should be compact. 0.68. What is the ratio of the Value added (current US$) of Sudan in 2008 to that in 2011?
Make the answer very short. 0.69. What is the ratio of the Value added (current US$) in Bosnia and Herzegovina in 2008 to that in 2012?
Give a very brief answer. 1.04. What is the ratio of the Value added (current US$) of Malawi in 2008 to that in 2012?
Give a very brief answer. 1.08. What is the ratio of the Value added (current US$) in Qatar in 2008 to that in 2012?
Keep it short and to the point. 0.6. What is the ratio of the Value added (current US$) in Sudan in 2008 to that in 2012?
Ensure brevity in your answer.  0.71. What is the ratio of the Value added (current US$) of Malawi in 2008 to that in 2013?
Your answer should be compact. 1.16. What is the ratio of the Value added (current US$) of Qatar in 2008 to that in 2013?
Make the answer very short. 0.53. What is the ratio of the Value added (current US$) of Sudan in 2008 to that in 2013?
Your answer should be very brief. 0.66. What is the ratio of the Value added (current US$) in Bosnia and Herzegovina in 2008 to that in 2014?
Make the answer very short. 0.96. What is the ratio of the Value added (current US$) of Malawi in 2008 to that in 2014?
Make the answer very short. 1.06. What is the ratio of the Value added (current US$) of Qatar in 2008 to that in 2014?
Give a very brief answer. 0.47. What is the ratio of the Value added (current US$) in Sudan in 2008 to that in 2014?
Your answer should be compact. 0.58. What is the ratio of the Value added (current US$) of Bosnia and Herzegovina in 2009 to that in 2010?
Offer a very short reply. 1.03. What is the ratio of the Value added (current US$) in Malawi in 2009 to that in 2010?
Make the answer very short. 0.94. What is the ratio of the Value added (current US$) in Qatar in 2009 to that in 2010?
Provide a succinct answer. 0.93. What is the ratio of the Value added (current US$) in Sudan in 2009 to that in 2010?
Provide a short and direct response. 0.84. What is the ratio of the Value added (current US$) in Bosnia and Herzegovina in 2009 to that in 2011?
Your response must be concise. 0.94. What is the ratio of the Value added (current US$) in Malawi in 2009 to that in 2011?
Offer a terse response. 0.93. What is the ratio of the Value added (current US$) in Qatar in 2009 to that in 2011?
Your response must be concise. 0.8. What is the ratio of the Value added (current US$) in Sudan in 2009 to that in 2011?
Keep it short and to the point. 0.81. What is the ratio of the Value added (current US$) in Bosnia and Herzegovina in 2009 to that in 2012?
Provide a short and direct response. 1. What is the ratio of the Value added (current US$) of Malawi in 2009 to that in 2012?
Offer a very short reply. 1.24. What is the ratio of the Value added (current US$) in Qatar in 2009 to that in 2012?
Keep it short and to the point. 0.7. What is the ratio of the Value added (current US$) of Sudan in 2009 to that in 2012?
Your response must be concise. 0.83. What is the ratio of the Value added (current US$) in Bosnia and Herzegovina in 2009 to that in 2013?
Offer a terse response. 0.95. What is the ratio of the Value added (current US$) in Malawi in 2009 to that in 2013?
Provide a short and direct response. 1.33. What is the ratio of the Value added (current US$) in Qatar in 2009 to that in 2013?
Provide a succinct answer. 0.63. What is the ratio of the Value added (current US$) in Sudan in 2009 to that in 2013?
Ensure brevity in your answer.  0.76. What is the ratio of the Value added (current US$) in Bosnia and Herzegovina in 2009 to that in 2014?
Provide a succinct answer. 0.92. What is the ratio of the Value added (current US$) of Malawi in 2009 to that in 2014?
Give a very brief answer. 1.22. What is the ratio of the Value added (current US$) in Qatar in 2009 to that in 2014?
Keep it short and to the point. 0.55. What is the ratio of the Value added (current US$) in Sudan in 2009 to that in 2014?
Your answer should be very brief. 0.68. What is the ratio of the Value added (current US$) in Bosnia and Herzegovina in 2010 to that in 2011?
Keep it short and to the point. 0.91. What is the ratio of the Value added (current US$) of Malawi in 2010 to that in 2011?
Your answer should be compact. 0.99. What is the ratio of the Value added (current US$) of Qatar in 2010 to that in 2011?
Offer a terse response. 0.85. What is the ratio of the Value added (current US$) in Sudan in 2010 to that in 2011?
Offer a very short reply. 0.96. What is the ratio of the Value added (current US$) in Bosnia and Herzegovina in 2010 to that in 2012?
Your answer should be compact. 0.97. What is the ratio of the Value added (current US$) of Malawi in 2010 to that in 2012?
Your response must be concise. 1.32. What is the ratio of the Value added (current US$) of Qatar in 2010 to that in 2012?
Offer a terse response. 0.75. What is the ratio of the Value added (current US$) in Sudan in 2010 to that in 2012?
Offer a very short reply. 0.98. What is the ratio of the Value added (current US$) of Bosnia and Herzegovina in 2010 to that in 2013?
Your answer should be very brief. 0.93. What is the ratio of the Value added (current US$) of Malawi in 2010 to that in 2013?
Offer a terse response. 1.42. What is the ratio of the Value added (current US$) of Qatar in 2010 to that in 2013?
Your answer should be very brief. 0.67. What is the ratio of the Value added (current US$) of Sudan in 2010 to that in 2013?
Provide a short and direct response. 0.91. What is the ratio of the Value added (current US$) in Bosnia and Herzegovina in 2010 to that in 2014?
Keep it short and to the point. 0.9. What is the ratio of the Value added (current US$) in Malawi in 2010 to that in 2014?
Provide a succinct answer. 1.29. What is the ratio of the Value added (current US$) of Qatar in 2010 to that in 2014?
Your answer should be very brief. 0.59. What is the ratio of the Value added (current US$) in Sudan in 2010 to that in 2014?
Your answer should be very brief. 0.8. What is the ratio of the Value added (current US$) in Bosnia and Herzegovina in 2011 to that in 2012?
Your answer should be compact. 1.06. What is the ratio of the Value added (current US$) of Malawi in 2011 to that in 2012?
Your answer should be compact. 1.33. What is the ratio of the Value added (current US$) in Qatar in 2011 to that in 2012?
Keep it short and to the point. 0.88. What is the ratio of the Value added (current US$) in Sudan in 2011 to that in 2012?
Provide a short and direct response. 1.02. What is the ratio of the Value added (current US$) in Bosnia and Herzegovina in 2011 to that in 2013?
Keep it short and to the point. 1.02. What is the ratio of the Value added (current US$) in Malawi in 2011 to that in 2013?
Give a very brief answer. 1.43. What is the ratio of the Value added (current US$) of Qatar in 2011 to that in 2013?
Offer a very short reply. 0.79. What is the ratio of the Value added (current US$) in Sudan in 2011 to that in 2013?
Offer a terse response. 0.95. What is the ratio of the Value added (current US$) of Bosnia and Herzegovina in 2011 to that in 2014?
Give a very brief answer. 0.98. What is the ratio of the Value added (current US$) of Malawi in 2011 to that in 2014?
Give a very brief answer. 1.3. What is the ratio of the Value added (current US$) of Qatar in 2011 to that in 2014?
Keep it short and to the point. 0.69. What is the ratio of the Value added (current US$) in Sudan in 2011 to that in 2014?
Your answer should be compact. 0.84. What is the ratio of the Value added (current US$) in Bosnia and Herzegovina in 2012 to that in 2013?
Your answer should be very brief. 0.96. What is the ratio of the Value added (current US$) of Malawi in 2012 to that in 2013?
Provide a succinct answer. 1.07. What is the ratio of the Value added (current US$) of Qatar in 2012 to that in 2013?
Your answer should be very brief. 0.89. What is the ratio of the Value added (current US$) of Sudan in 2012 to that in 2013?
Offer a very short reply. 0.92. What is the ratio of the Value added (current US$) of Bosnia and Herzegovina in 2012 to that in 2014?
Ensure brevity in your answer.  0.92. What is the ratio of the Value added (current US$) in Malawi in 2012 to that in 2014?
Offer a very short reply. 0.98. What is the ratio of the Value added (current US$) of Qatar in 2012 to that in 2014?
Offer a very short reply. 0.78. What is the ratio of the Value added (current US$) of Sudan in 2012 to that in 2014?
Ensure brevity in your answer.  0.82. What is the ratio of the Value added (current US$) of Bosnia and Herzegovina in 2013 to that in 2014?
Offer a very short reply. 0.97. What is the ratio of the Value added (current US$) of Malawi in 2013 to that in 2014?
Your answer should be very brief. 0.91. What is the ratio of the Value added (current US$) in Qatar in 2013 to that in 2014?
Your response must be concise. 0.88. What is the ratio of the Value added (current US$) in Sudan in 2013 to that in 2014?
Ensure brevity in your answer.  0.88. What is the difference between the highest and the second highest Value added (current US$) in Bosnia and Herzegovina?
Keep it short and to the point. 1.67e+08. What is the difference between the highest and the second highest Value added (current US$) of Malawi?
Your answer should be compact. 1.59e+07. What is the difference between the highest and the second highest Value added (current US$) of Qatar?
Your answer should be very brief. 8.03e+09. What is the difference between the highest and the second highest Value added (current US$) of Sudan?
Give a very brief answer. 4.22e+09. What is the difference between the highest and the lowest Value added (current US$) of Bosnia and Herzegovina?
Offer a very short reply. 2.24e+09. What is the difference between the highest and the lowest Value added (current US$) of Malawi?
Give a very brief answer. 8.66e+08. What is the difference between the highest and the lowest Value added (current US$) in Qatar?
Make the answer very short. 4.10e+1. What is the difference between the highest and the lowest Value added (current US$) in Sudan?
Offer a terse response. 1.78e+1. 